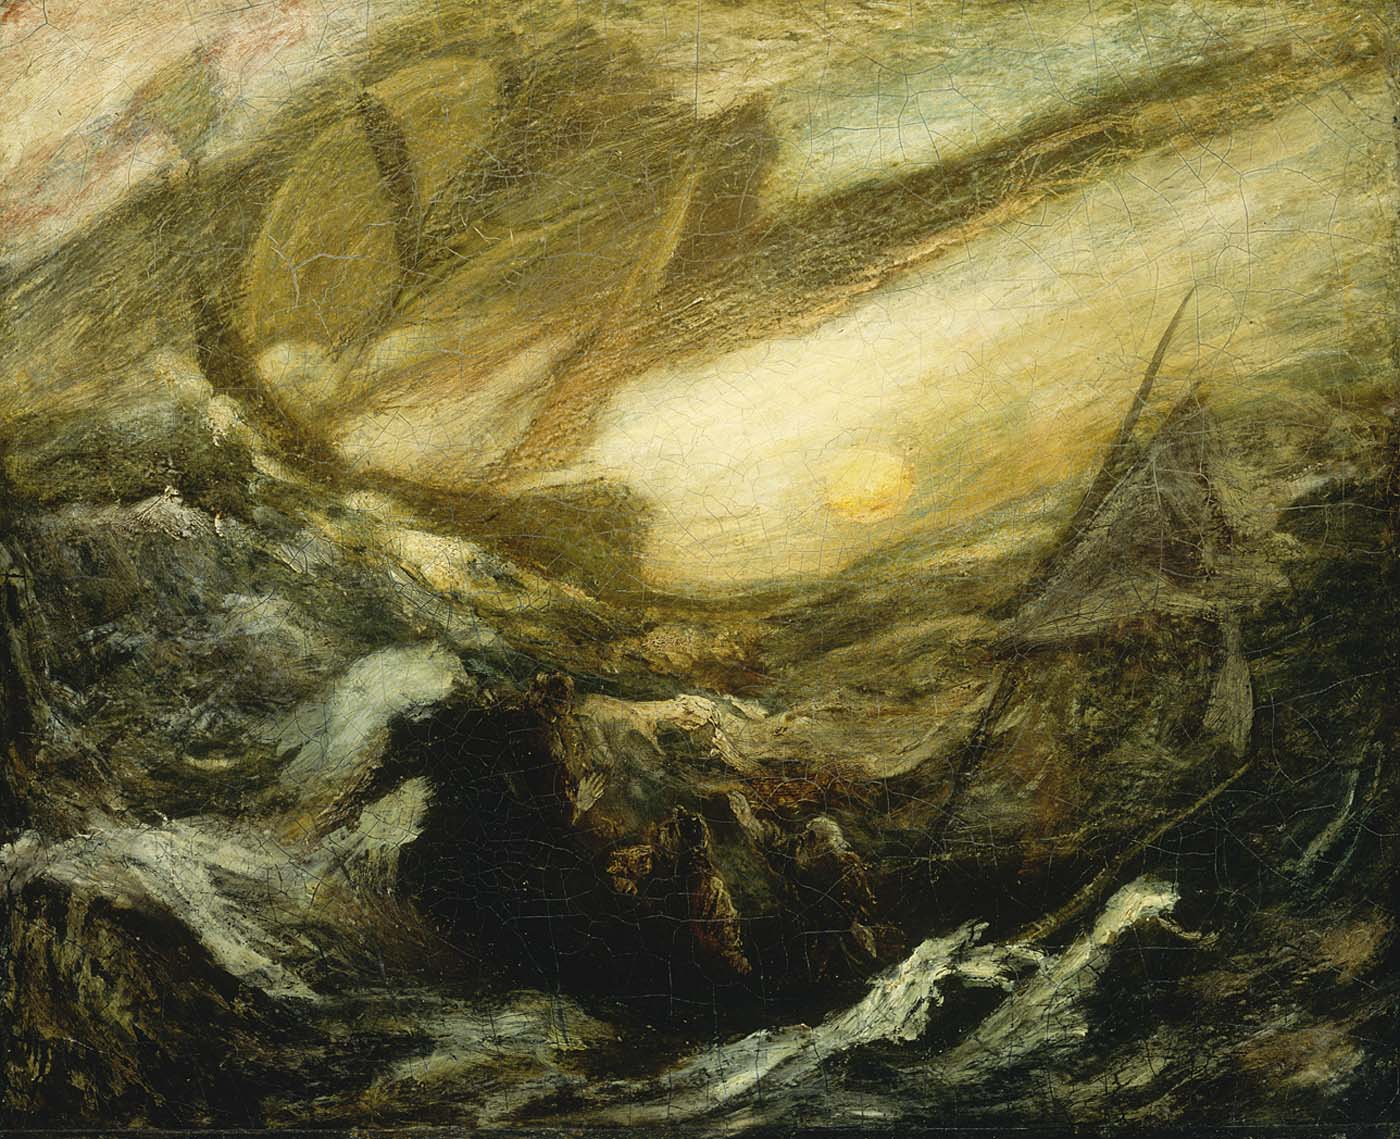What might be the historical context behind this painting? This painting might be rooted in the era of exploration and maritime adventure, where the sea was both a frontier and a formidable foe. It could reflect the experiences of sailors and explorers during the Age of Sail, when ocean voyages were fraught with peril yet filled with the promise of discovery. Alternatively, it may represent a mythological or literary scene, such as the epic voyages in works like Homer's Odyssey, where heroes faced monstrous storms and mythical beasts. The painting, with its timeless and universal themes, invites viewers to ponder the historical and narrative layers embedded within the tumultuous seascape. 